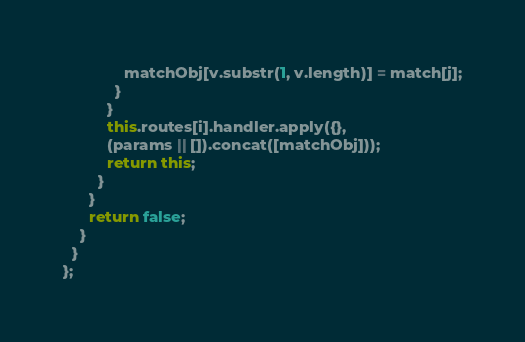Convert code to text. <code><loc_0><loc_0><loc_500><loc_500><_JavaScript_>              matchObj[v.substr(1, v.length)] = match[j];
            }
          }
          this.routes[i].handler.apply({},
          (params || []).concat([matchObj]));
          return this;
        }
      }
      return false;
    }
  }
};
</code> 